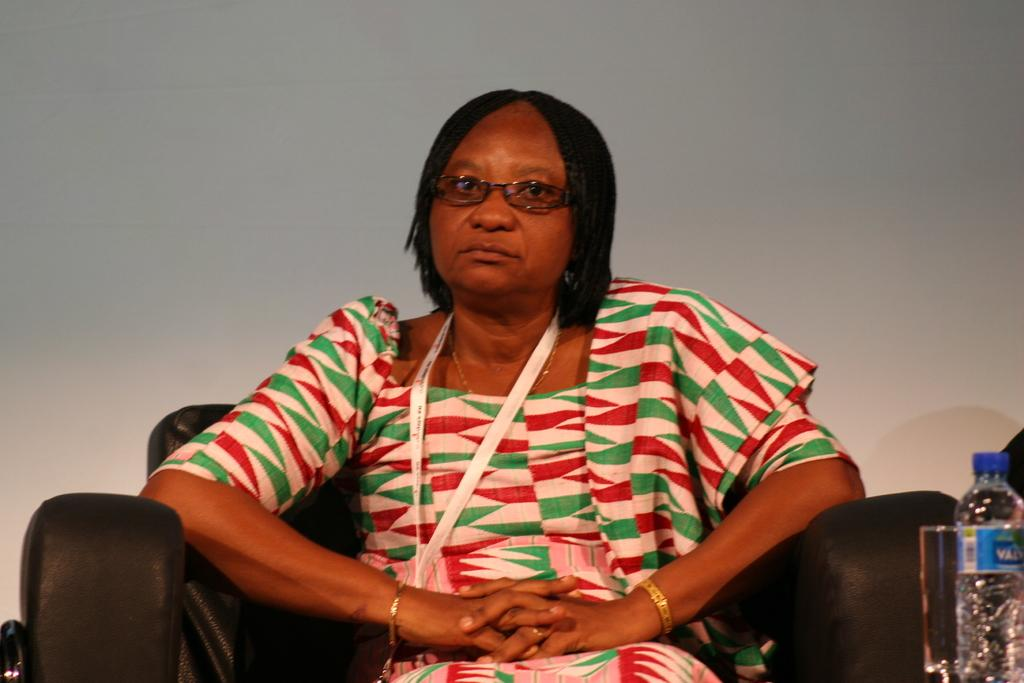What is the woman in the image doing? The woman is sitting in the chair. What can be seen on the right side of the image? There is a water bottle on the right side. What is visible behind the woman in the image? There is a wall behind the woman. How many oranges are on the floor in the image? There are no oranges present in the image. What type of humor is depicted in the image? The image does not depict any humor; it simply shows a woman sitting in a chair with a water bottle and a wall behind her. 